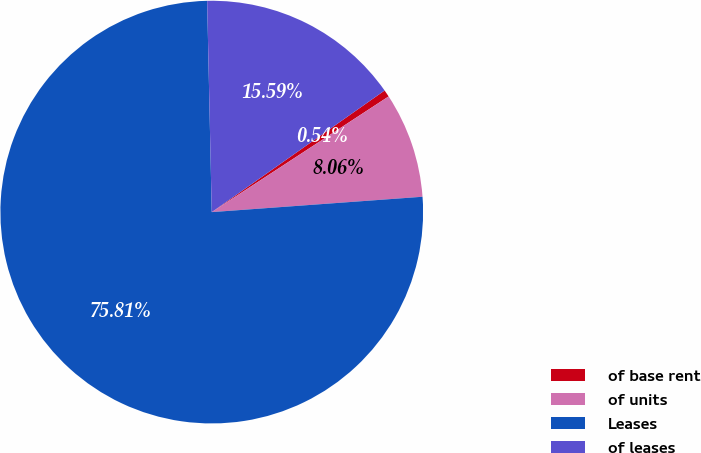<chart> <loc_0><loc_0><loc_500><loc_500><pie_chart><fcel>of base rent<fcel>of units<fcel>Leases<fcel>of leases<nl><fcel>0.54%<fcel>8.06%<fcel>75.81%<fcel>15.59%<nl></chart> 